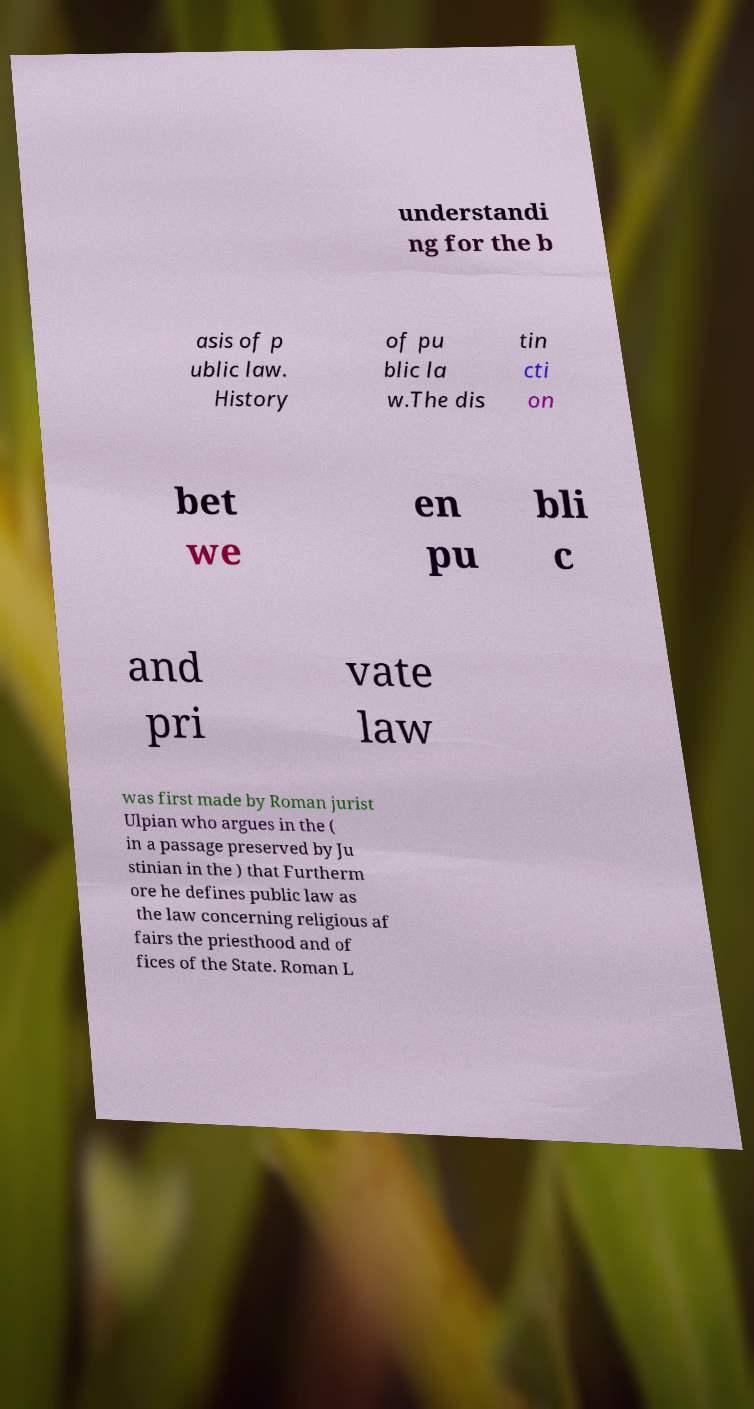Please identify and transcribe the text found in this image. understandi ng for the b asis of p ublic law. History of pu blic la w.The dis tin cti on bet we en pu bli c and pri vate law was first made by Roman jurist Ulpian who argues in the ( in a passage preserved by Ju stinian in the ) that Furtherm ore he defines public law as the law concerning religious af fairs the priesthood and of fices of the State. Roman L 